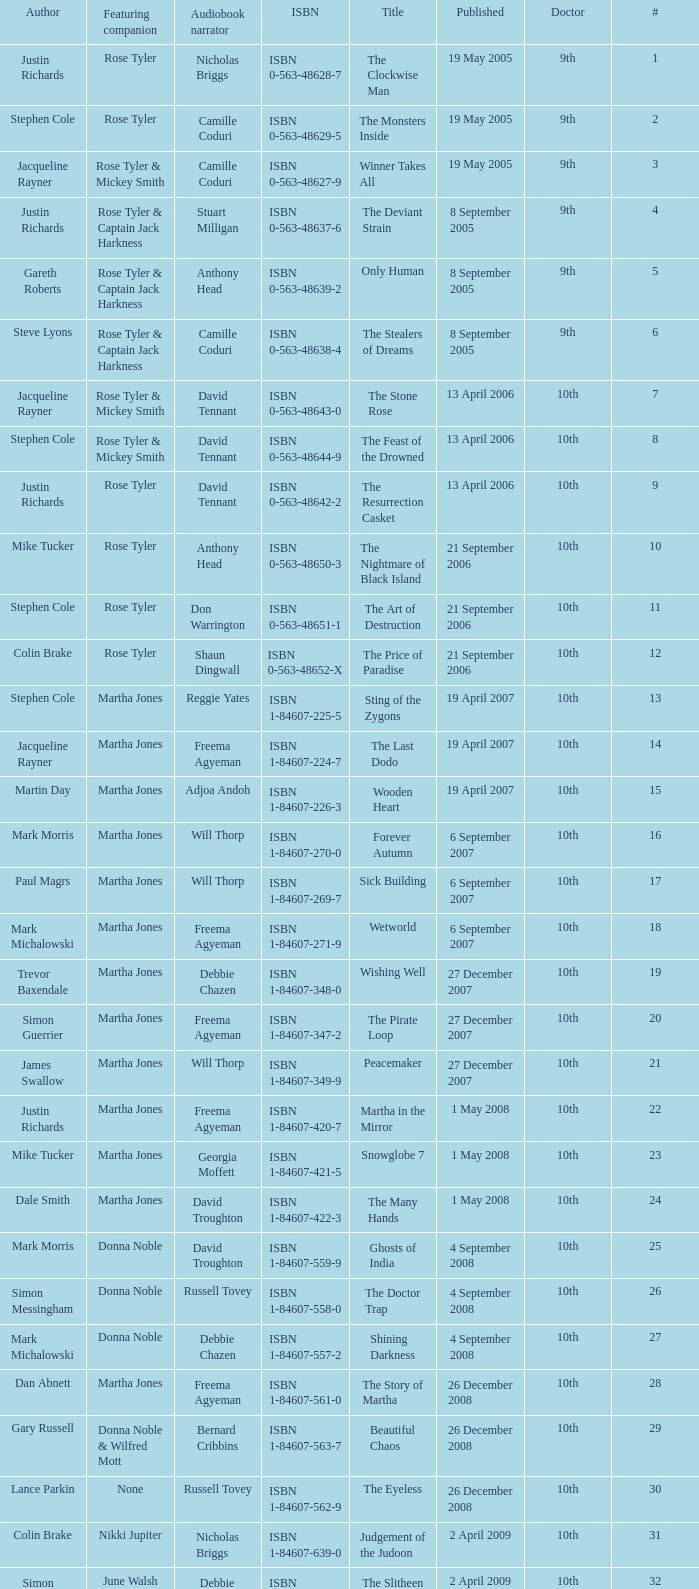What is the title of book number 8? The Feast of the Drowned. 